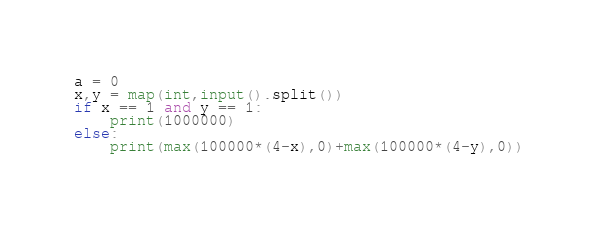Convert code to text. <code><loc_0><loc_0><loc_500><loc_500><_Python_>a = 0
x,y = map(int,input().split())
if x == 1 and y == 1:
    print(1000000)
else:
    print(max(100000*(4-x),0)+max(100000*(4-y),0))</code> 